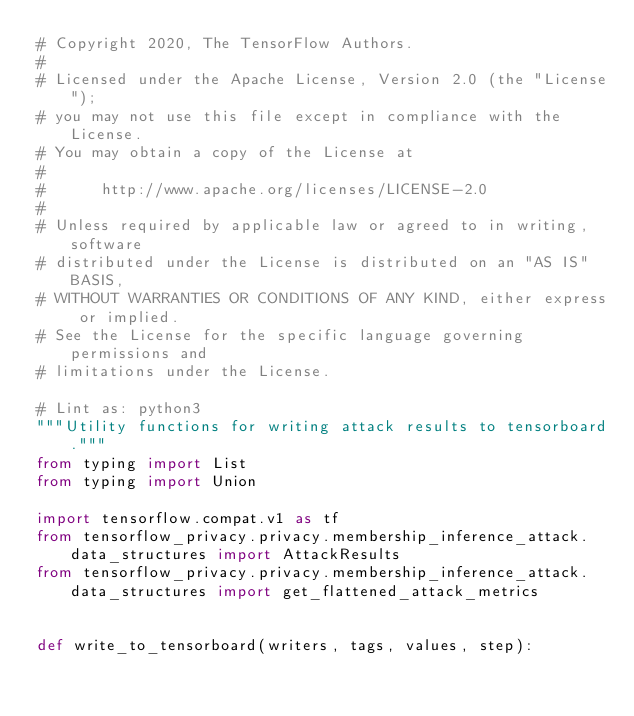<code> <loc_0><loc_0><loc_500><loc_500><_Python_># Copyright 2020, The TensorFlow Authors.
#
# Licensed under the Apache License, Version 2.0 (the "License");
# you may not use this file except in compliance with the License.
# You may obtain a copy of the License at
#
#      http://www.apache.org/licenses/LICENSE-2.0
#
# Unless required by applicable law or agreed to in writing, software
# distributed under the License is distributed on an "AS IS" BASIS,
# WITHOUT WARRANTIES OR CONDITIONS OF ANY KIND, either express or implied.
# See the License for the specific language governing permissions and
# limitations under the License.

# Lint as: python3
"""Utility functions for writing attack results to tensorboard."""
from typing import List
from typing import Union

import tensorflow.compat.v1 as tf
from tensorflow_privacy.privacy.membership_inference_attack.data_structures import AttackResults
from tensorflow_privacy.privacy.membership_inference_attack.data_structures import get_flattened_attack_metrics


def write_to_tensorboard(writers, tags, values, step):</code> 